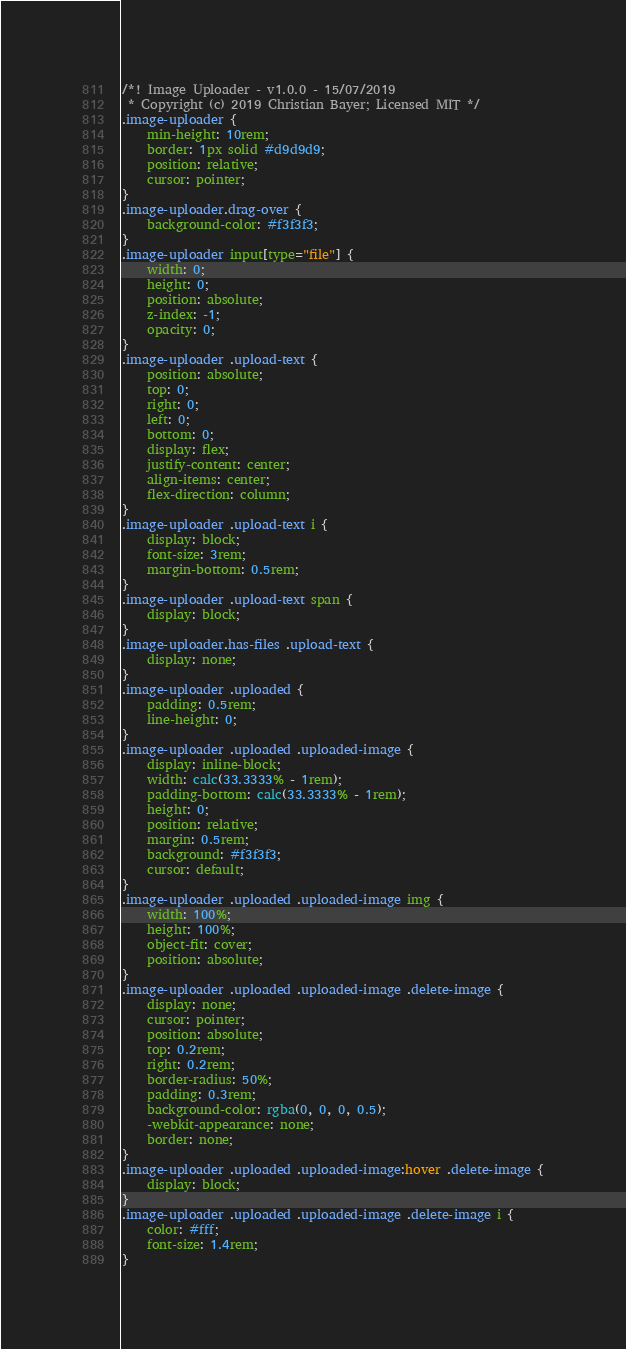Convert code to text. <code><loc_0><loc_0><loc_500><loc_500><_CSS_>/*! Image Uploader - v1.0.0 - 15/07/2019
 * Copyright (c) 2019 Christian Bayer; Licensed MIT */
.image-uploader {
    min-height: 10rem;
    border: 1px solid #d9d9d9;
    position: relative;
    cursor: pointer;
}
.image-uploader.drag-over {
    background-color: #f3f3f3;
}
.image-uploader input[type="file"] {
    width: 0;
    height: 0;
    position: absolute;
    z-index: -1;
    opacity: 0;
}
.image-uploader .upload-text {
    position: absolute;
    top: 0;
    right: 0;
    left: 0;
    bottom: 0;
    display: flex;
    justify-content: center;
    align-items: center;
    flex-direction: column;
}
.image-uploader .upload-text i {
    display: block;
    font-size: 3rem;
    margin-bottom: 0.5rem;
}
.image-uploader .upload-text span {
    display: block;
}
.image-uploader.has-files .upload-text {
    display: none;
}
.image-uploader .uploaded {
    padding: 0.5rem;
    line-height: 0;
}
.image-uploader .uploaded .uploaded-image {
    display: inline-block;
    width: calc(33.3333% - 1rem);
    padding-bottom: calc(33.3333% - 1rem);
    height: 0;
    position: relative;
    margin: 0.5rem;
    background: #f3f3f3;
    cursor: default;
}
.image-uploader .uploaded .uploaded-image img {
    width: 100%;
    height: 100%;
    object-fit: cover;
    position: absolute;
}
.image-uploader .uploaded .uploaded-image .delete-image {
    display: none;
    cursor: pointer;
    position: absolute;
    top: 0.2rem;
    right: 0.2rem;
    border-radius: 50%;
    padding: 0.3rem;
    background-color: rgba(0, 0, 0, 0.5);
    -webkit-appearance: none;
    border: none;
}
.image-uploader .uploaded .uploaded-image:hover .delete-image {
    display: block;
}
.image-uploader .uploaded .uploaded-image .delete-image i {
    color: #fff;
    font-size: 1.4rem;
}
</code> 